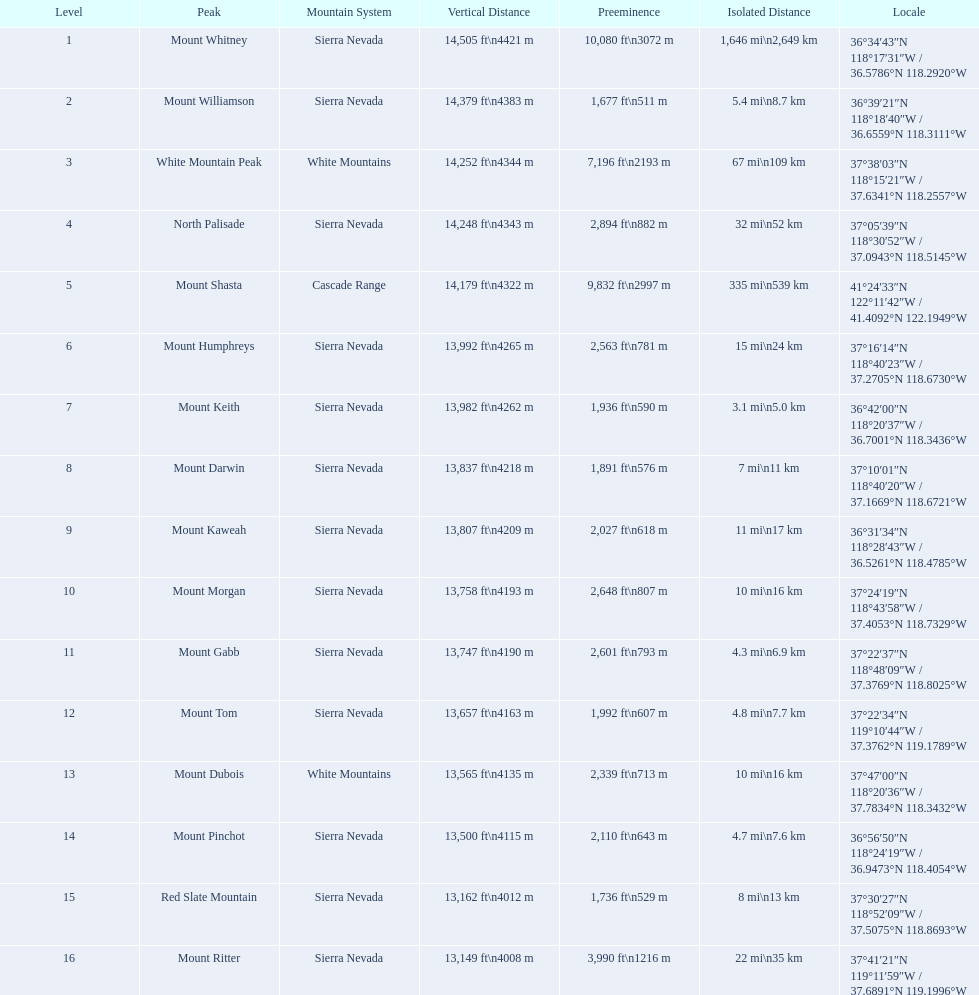What are the mountain peaks? Mount Whitney, Mount Williamson, White Mountain Peak, North Palisade, Mount Shasta, Mount Humphreys, Mount Keith, Mount Darwin, Mount Kaweah, Mount Morgan, Mount Gabb, Mount Tom, Mount Dubois, Mount Pinchot, Red Slate Mountain, Mount Ritter. Of these, which one has a prominence more than 10,000 ft? Mount Whitney. 